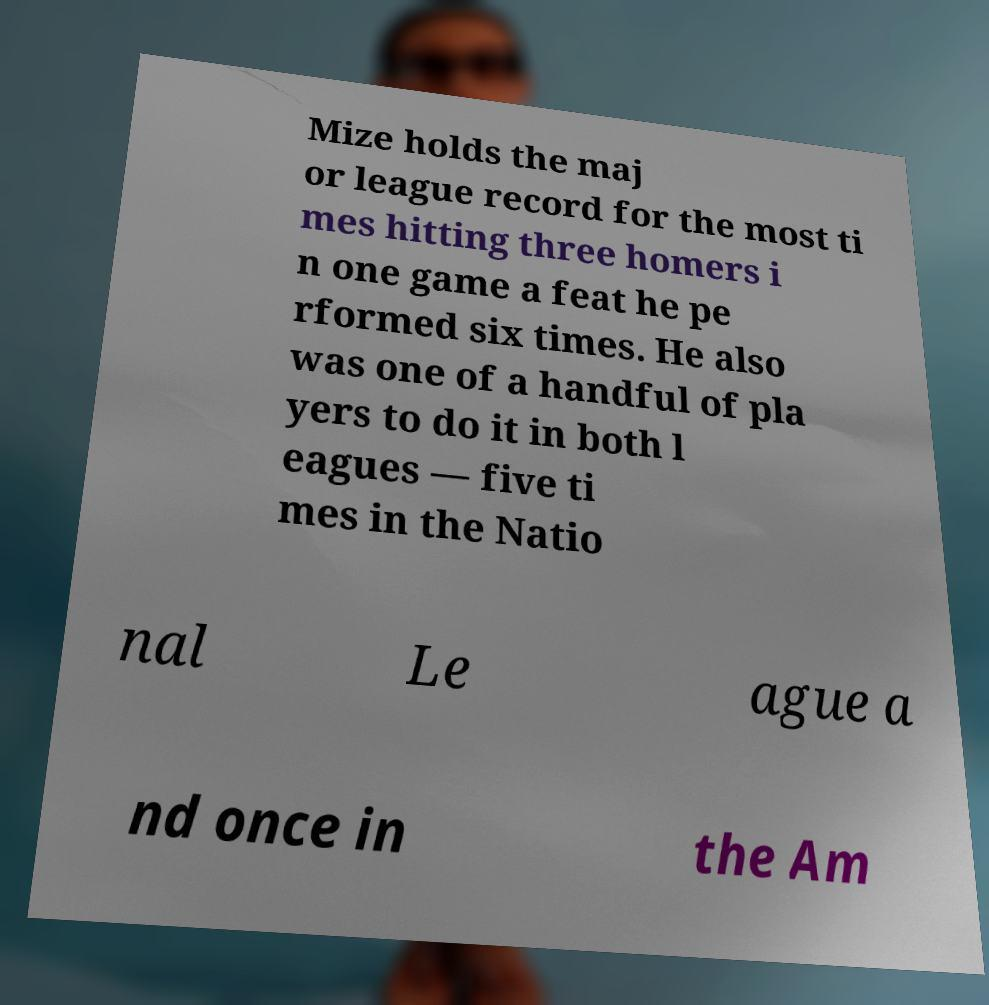Could you assist in decoding the text presented in this image and type it out clearly? Mize holds the maj or league record for the most ti mes hitting three homers i n one game a feat he pe rformed six times. He also was one of a handful of pla yers to do it in both l eagues — five ti mes in the Natio nal Le ague a nd once in the Am 